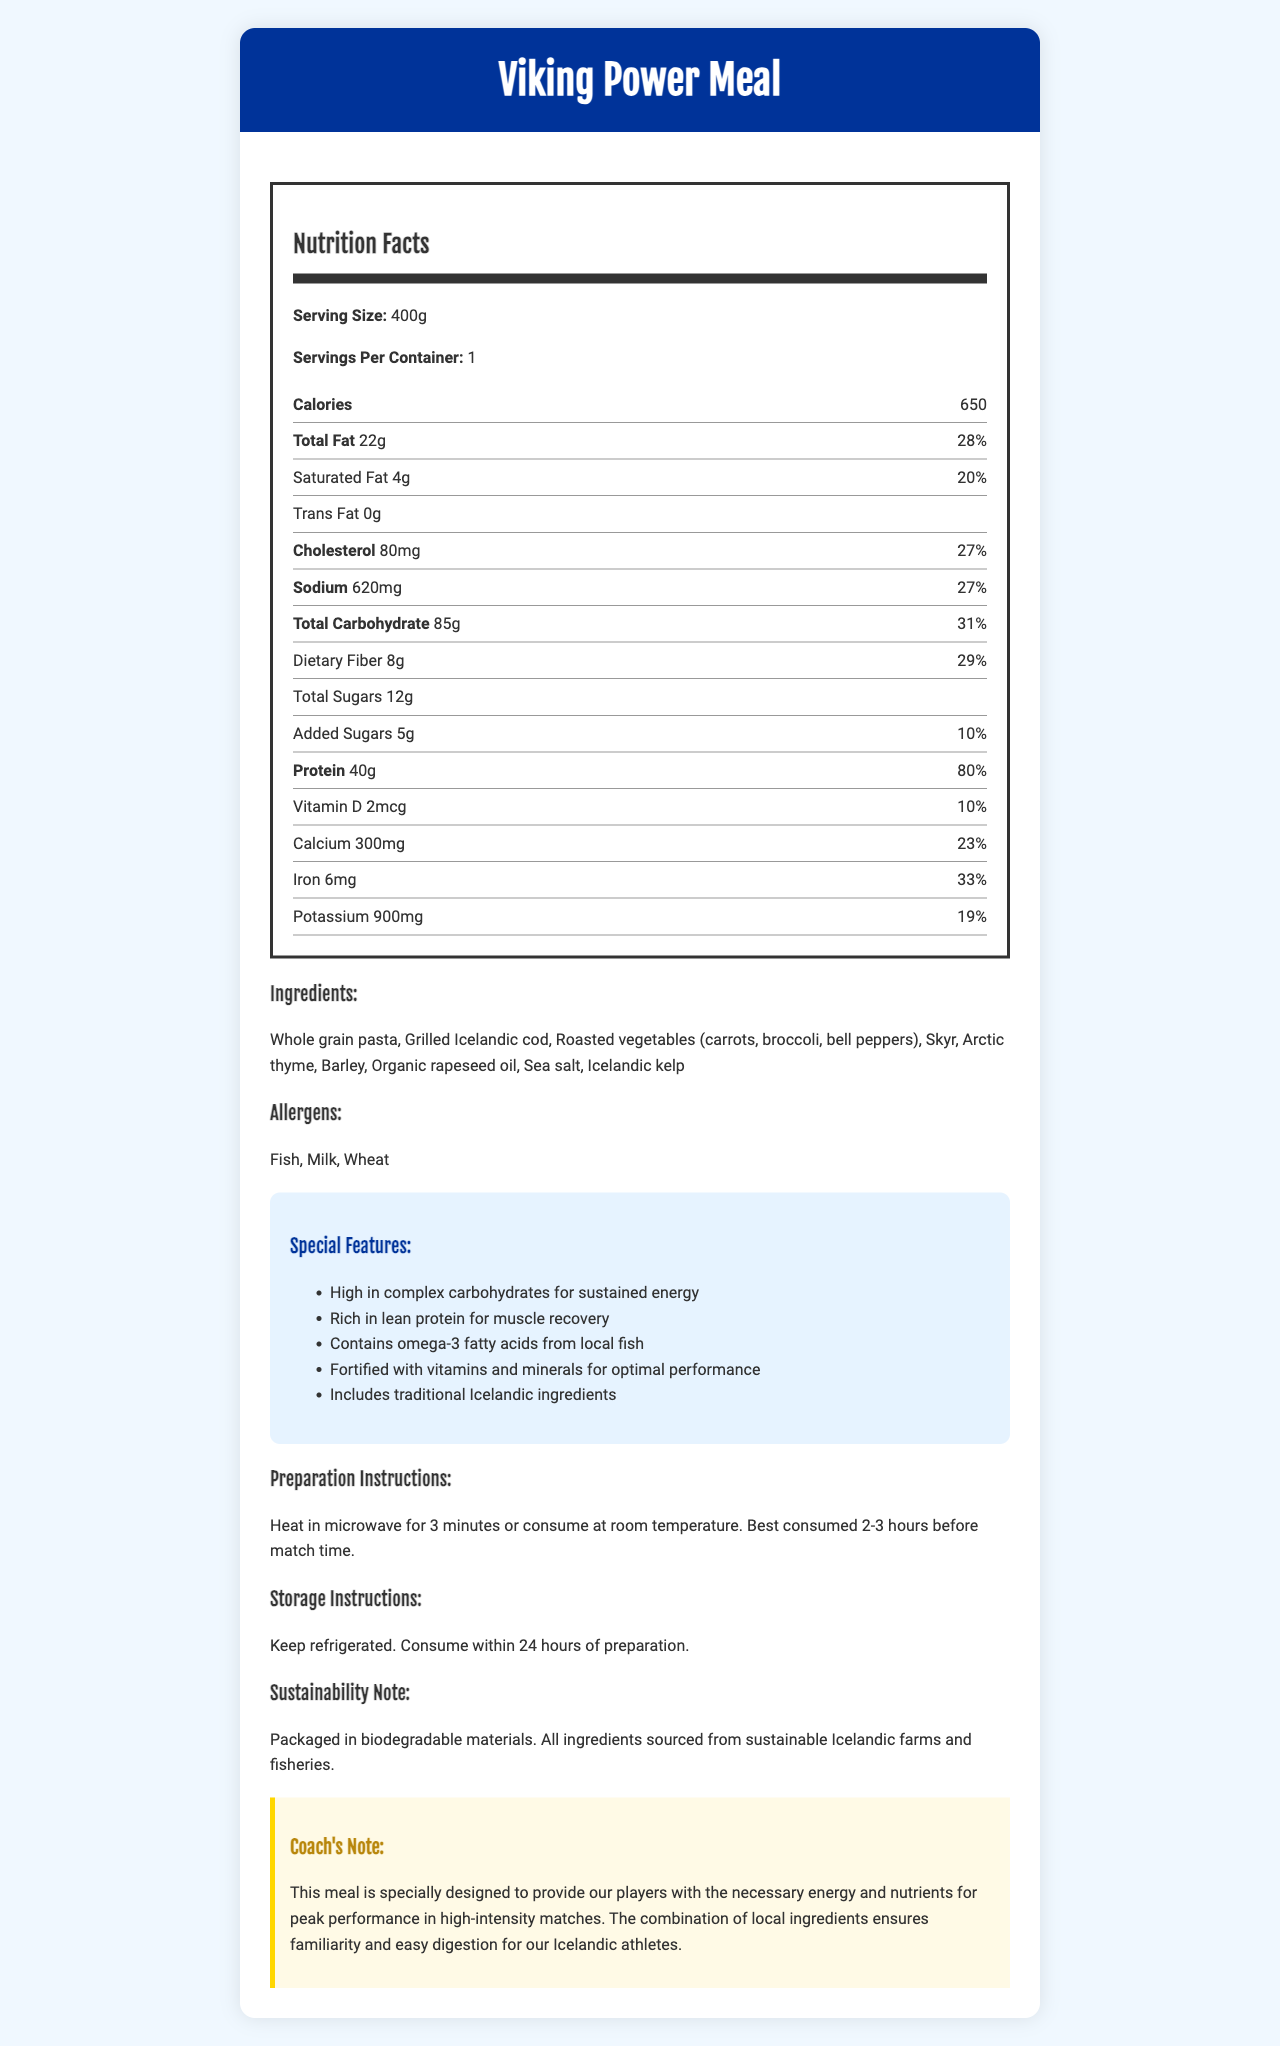what is the serving size for the Viking Power Meal? The serving size is mentioned directly under "Nutrition Facts" and is stated as "Serving Size: 400g."
Answer: 400g how many calories are in one serving of the Viking Power Meal? The number of calories per serving is stated under the "Calories" section, which lists "Calories 650."
Answer: 650 list the ingredients of the Viking Power Meal. The ingredients are listed in the "Ingredients" section of the document.
Answer: Whole grain pasta, Grilled Icelandic cod, Roasted vegetables (carrots, broccoli, bell peppers), Skyr, Arctic thyme, Barley, Organic rapeseed oil, Sea salt, Icelandic kelp which nutrient has the highest daily value percentage? The nutrient with the highest daily value percentage is protein, with an 80% daily value.
Answer: Protein are there any allergens in the Viking Power Meal? The "Allergens" section lists Fish, Milk, and Wheat, indicating the presence of these allergens.
Answer: Yes how should the Viking Power Meal be prepared? The preparation method is provided in the "Preparation Instructions" section.
Answer: Heat in microwave for 3 minutes or consume at room temperature. Best consumed 2-3 hours before match time. which vitamin is included in the Viking Power Meal? A. Vitamin A B. Vitamin B6 C. Vitamin D D. Vitamin C The document lists "Vitamin D" under the "Nutrition Facts" section.
Answer: C what is the daily value percentage for dietary fiber in the Viking Power Meal? The daily value percentage for dietary fiber is listed as 29% in the "Nutrition Facts" section.
Answer: 29% how many grams of protein does the Viking Power Meal contain? The protein content is listed as 40g in the "Nutrition Facts" section.
Answer: 40g which one of the following is not a special feature of the Viking Power Meal? A. High in fiber B. Rich in lean protein C. Contains omega-3 fatty acids D. Fortified with vitamins and minerals The special features listed do not mention "High in fiber." They focus on complex carbohydrates, lean protein, omega-3 fatty acids, and vitamins and minerals.
Answer: A what is the combination of carbohydrates and dietary fiber in one serving? The total carbohydrate is 85g, and the dietary fiber is 8g. The sum is 93g.
Answer: 93g is the Viking Power Meal suitable for someone with a milk allergy? The allergens section lists "Milk," indicating that the product contains milk and is not suitable for someone with a milk allergy.
Answer: No summarize the main idea of the document. The summary encapsulates the essential information provided by the document, including its purpose, nutritional components, and special considerations.
Answer: The document outlines the nutrition facts, ingredients, allergens, special features, preparation and storage instructions, and a coach's note for the Viking Power Meal, a high-energy pre-match meal designed for the Icelandic national football team. The meal emphasizes local ingredients, high protein, and complex carbohydrates to enhance player performance. can the exact amount of omega-3 fatty acids be determined from the document? The document mentions that the meal contains omega-3 fatty acids from local fish but does not provide the exact amount.
Answer: No what sustainability practices are mentioned in the document? The sustainability practices are mentioned in the "Sustainability Note" section, explaining the packaging and sourcing methods.
Answer: Packaged in biodegradable materials. All ingredients sourced from sustainable Icelandic farms and fisheries. which ingredient is rich in lean protein and commonly used in Iceland? The "Ingredients" list includes Grilled Icelandic cod, which is known for being a lean protein and a common component of Icelandic cuisine.
Answer: Grilled Icelandic cod 